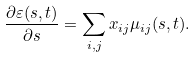Convert formula to latex. <formula><loc_0><loc_0><loc_500><loc_500>\frac { \partial \varepsilon ( s , t ) } { \partial s } = \sum _ { i , j } x _ { i j } \mu _ { i j } ( s , t ) .</formula> 